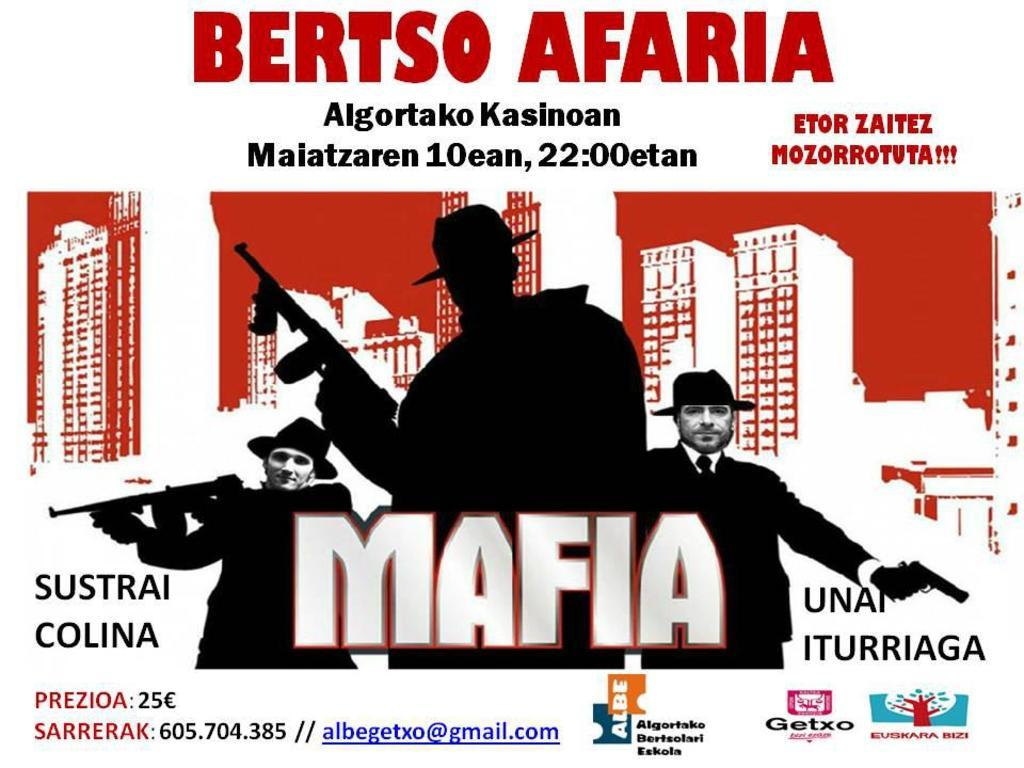What is present in the image that contains information or a message? There is a poster in the image that contains text. What else can be seen on the poster besides the text? There are images of persons and buildings on the poster. What type of lace can be seen on the door in the image? There is no door or lace present in the image; it only features a poster with text and images. 